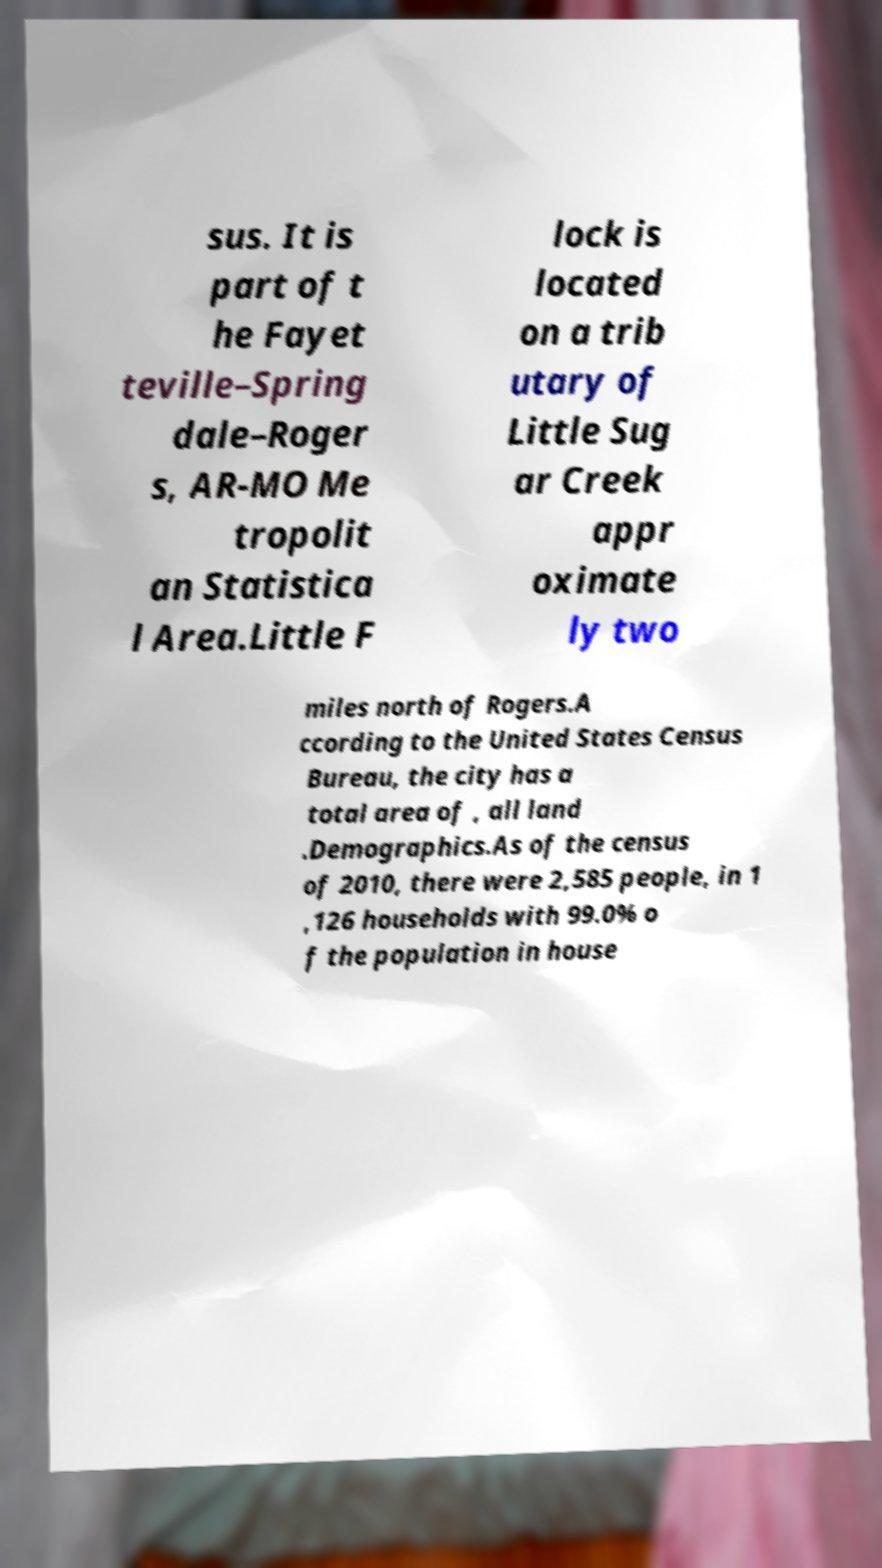Please identify and transcribe the text found in this image. sus. It is part of t he Fayet teville–Spring dale–Roger s, AR-MO Me tropolit an Statistica l Area.Little F lock is located on a trib utary of Little Sug ar Creek appr oximate ly two miles north of Rogers.A ccording to the United States Census Bureau, the city has a total area of , all land .Demographics.As of the census of 2010, there were 2,585 people, in 1 ,126 households with 99.0% o f the population in house 